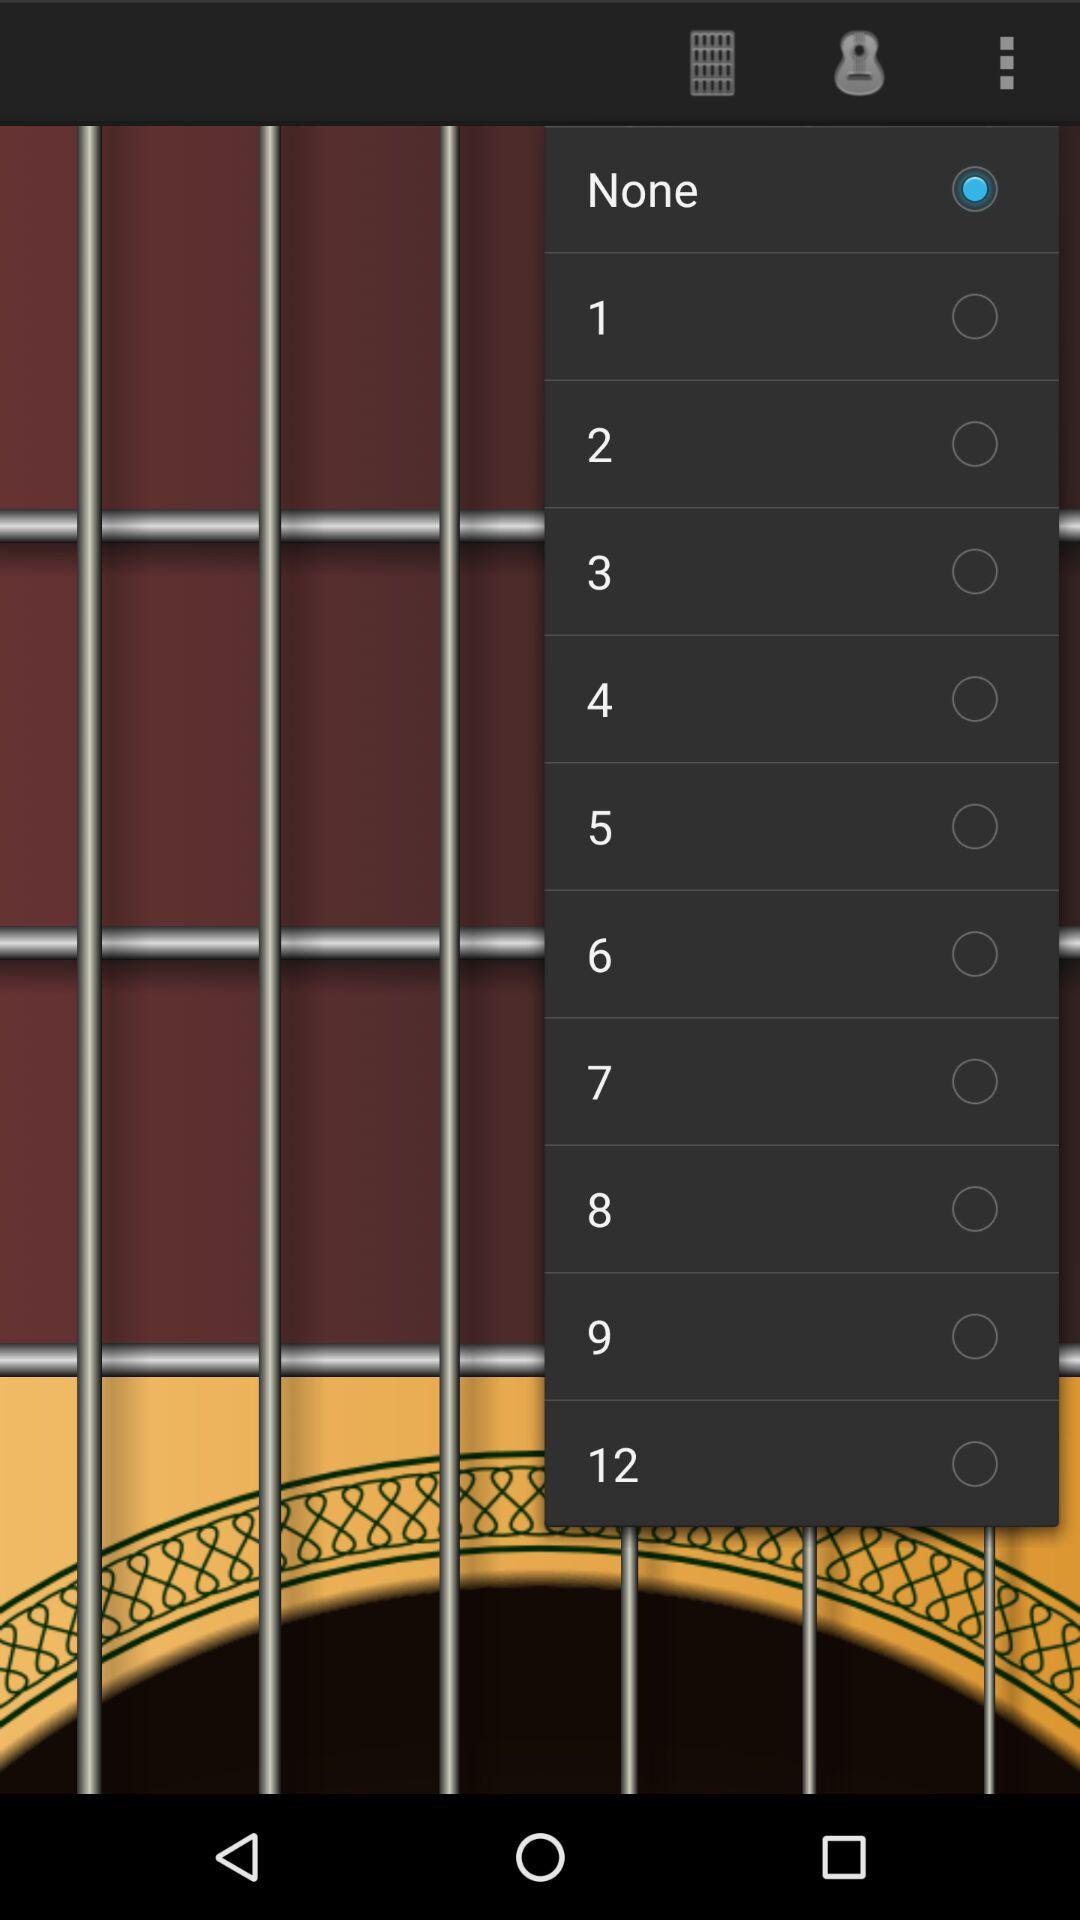How many numbers are there?
Answer the question using a single word or phrase. 12 